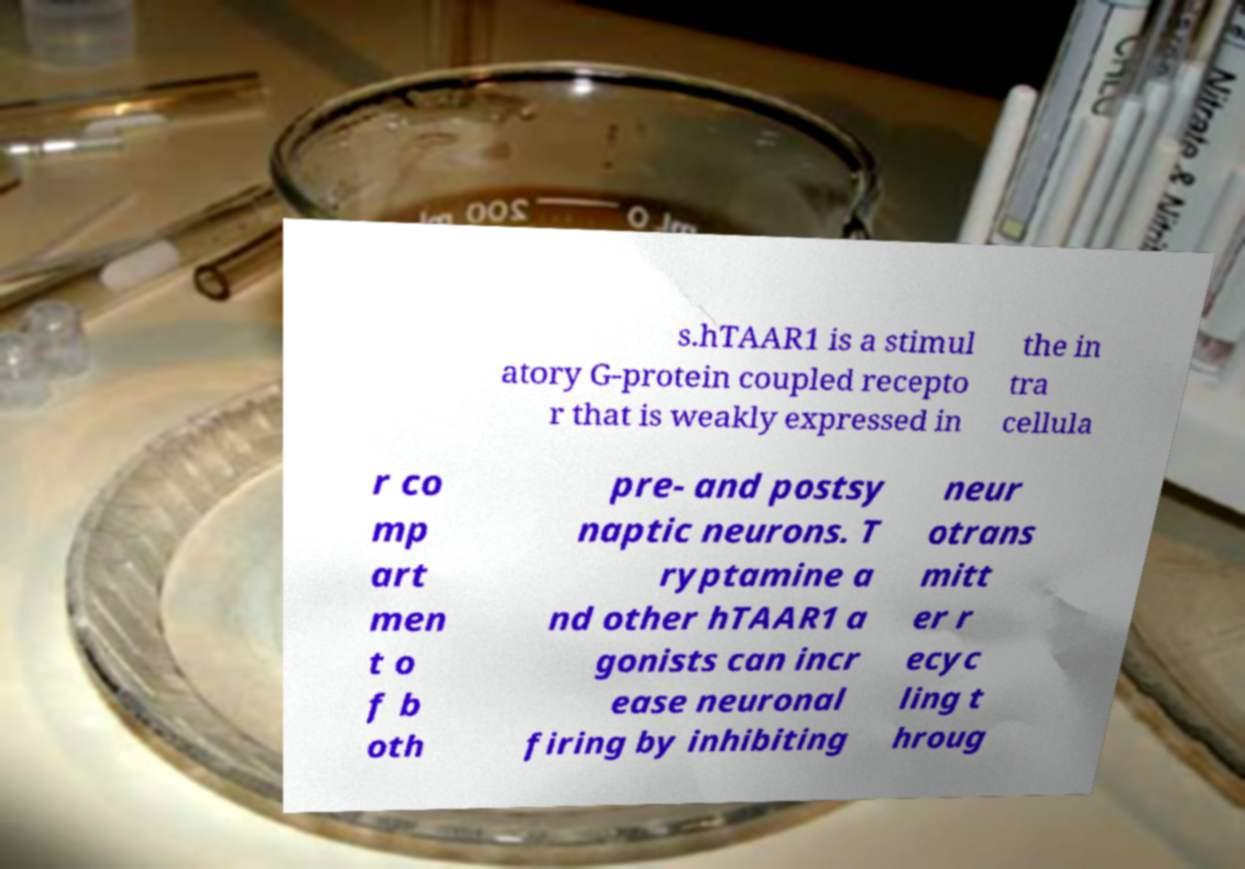Can you read and provide the text displayed in the image?This photo seems to have some interesting text. Can you extract and type it out for me? s.hTAAR1 is a stimul atory G-protein coupled recepto r that is weakly expressed in the in tra cellula r co mp art men t o f b oth pre- and postsy naptic neurons. T ryptamine a nd other hTAAR1 a gonists can incr ease neuronal firing by inhibiting neur otrans mitt er r ecyc ling t hroug 